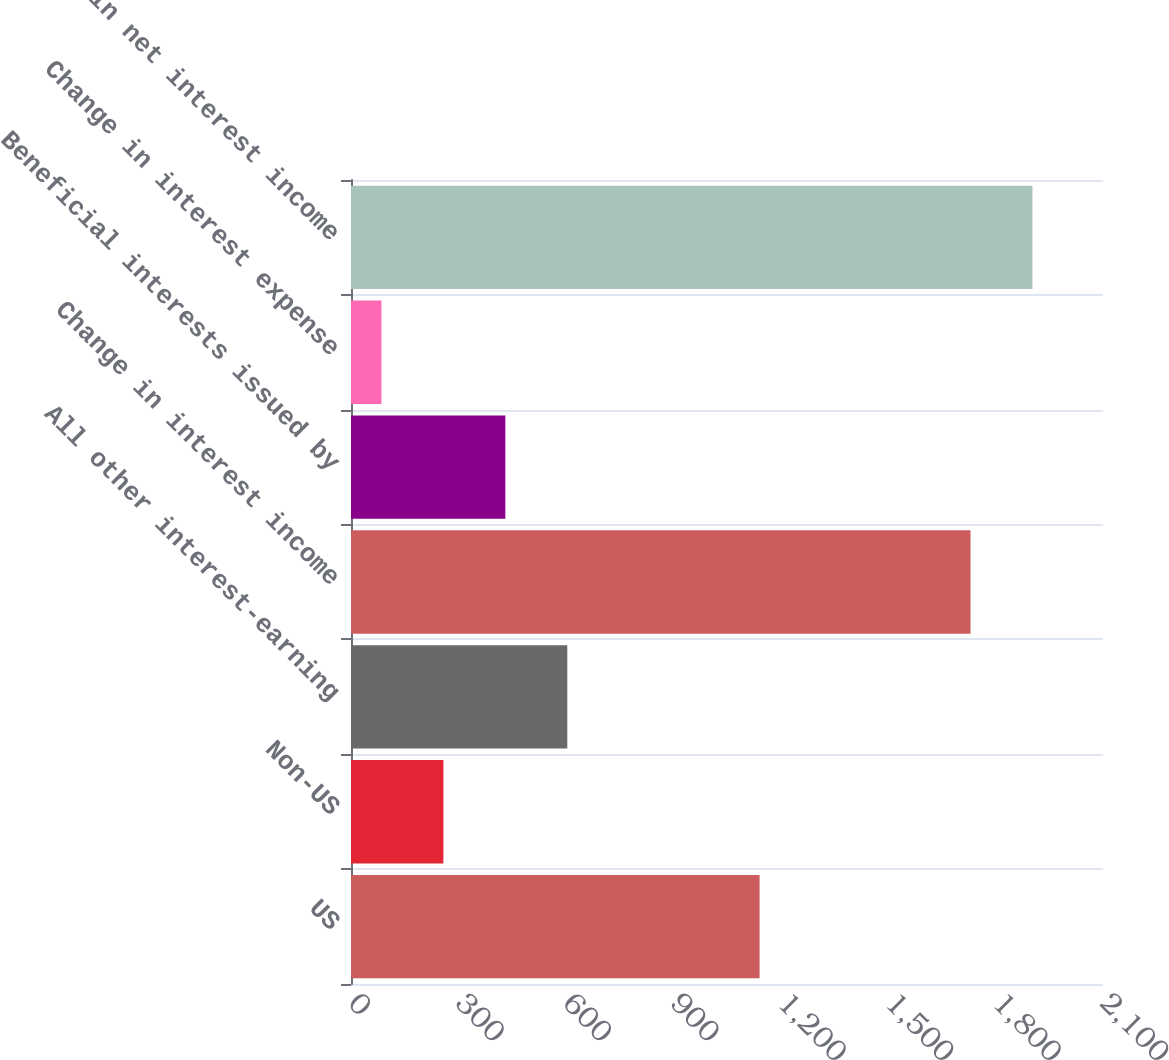Convert chart. <chart><loc_0><loc_0><loc_500><loc_500><bar_chart><fcel>US<fcel>Non-US<fcel>All other interest-earning<fcel>Change in interest income<fcel>Beneficial interests issued by<fcel>Change in interest expense<fcel>Change in net interest income<nl><fcel>1141<fcel>258<fcel>604<fcel>1730<fcel>431<fcel>85<fcel>1903<nl></chart> 